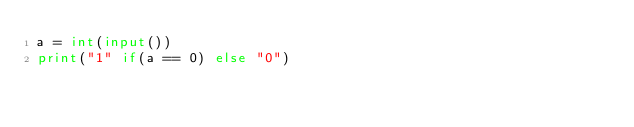<code> <loc_0><loc_0><loc_500><loc_500><_Python_>a = int(input())
print("1" if(a == 0) else "0")</code> 